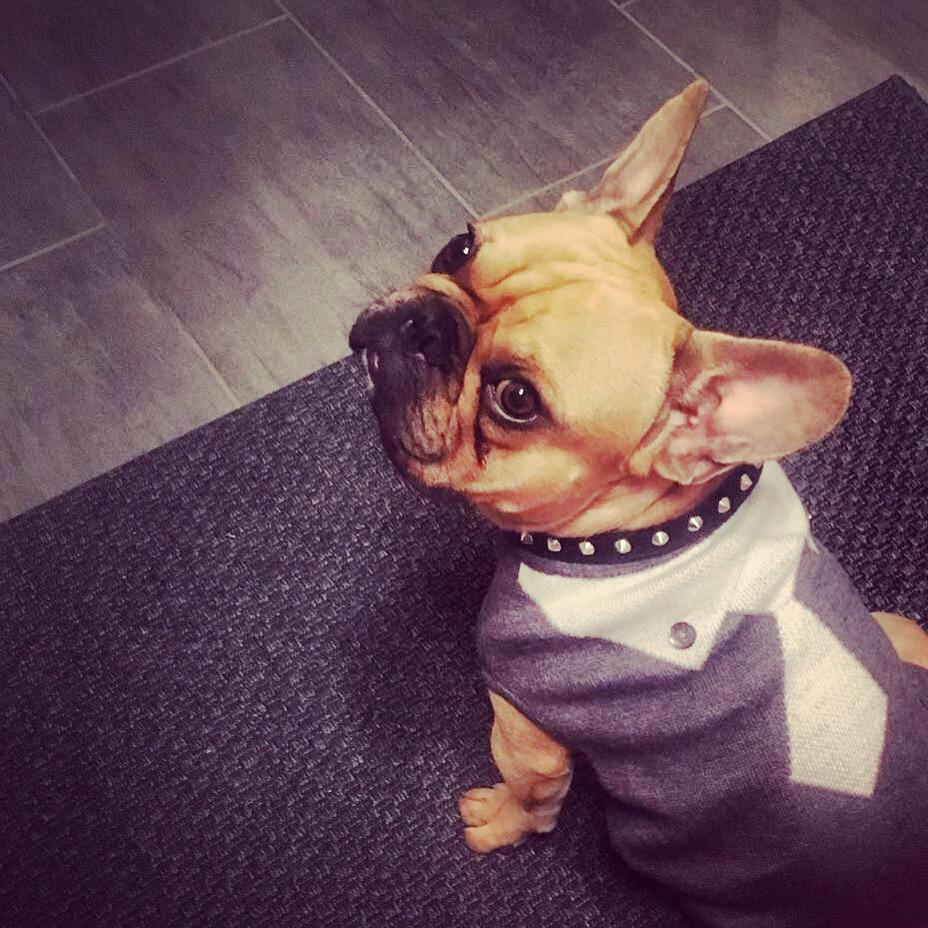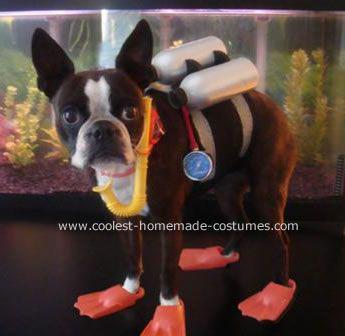The first image is the image on the left, the second image is the image on the right. Evaluate the accuracy of this statement regarding the images: "A dog can be seen sitting on a carpet.". Is it true? Answer yes or no. Yes. The first image is the image on the left, the second image is the image on the right. For the images displayed, is the sentence "At least two dogs are wearing costumes." factually correct? Answer yes or no. Yes. 